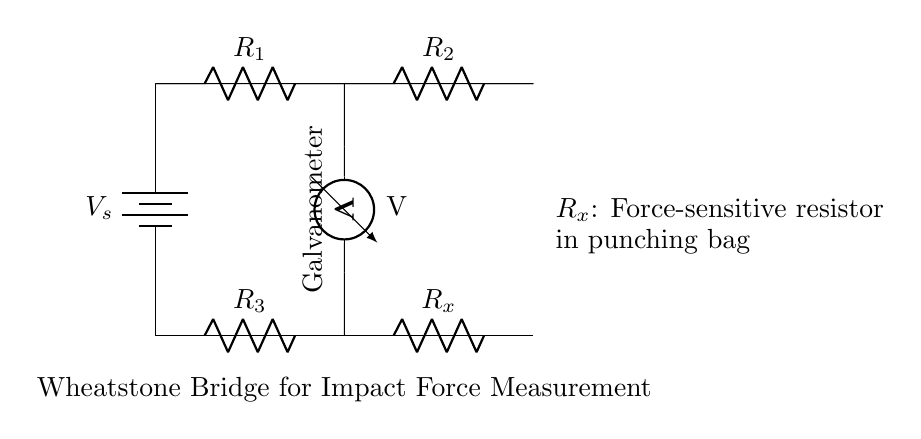What is the source voltage in the circuit? The source voltage, labeled as V_s in the diagram, is the potential difference provided by the battery at the top left of the circuit.
Answer: V_s What type of resistor is R_x? R_x is a force-sensitive resistor, indicated by the label in the circuit diagram, which responds to the impact force applied when hitting the punching bag.
Answer: Force-sensitive resistor How many resistors are in the Wheatstone bridge? The Wheatstone bridge consists of four resistors: R_1, R_2, R_3, and R_x as shown in the arrangement.
Answer: Four resistors What does the voltmeter measure in the circuit? The voltmeter measures the voltage difference across the two branches of the Wheatstone bridge, giving an indication of the balance condition of the bridge and ultimately the impact force.
Answer: Voltage If R_1 and R_2 are equal, what can be said about R_3 and R_x? If R_1 equals R_2, then R_3 must equal R_x for the bridge to be balanced, indicating that the impact force measured is within expected limits.
Answer: R_3 equals R_x What is represented by the galvanometer in this circuit? The galvanometer represents the device used to detect the current flowing through the circuit, indicating an imbalance in the bridge which correlates to the force measured by R_x.
Answer: Galvanometer 